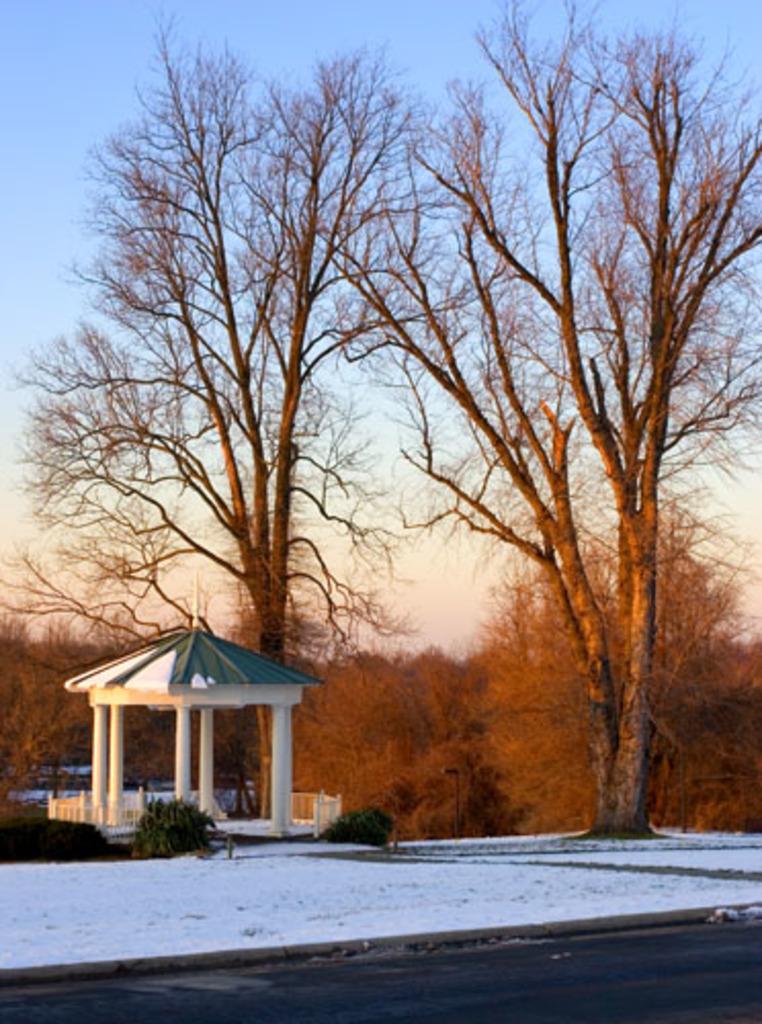In one or two sentences, can you explain what this image depicts? This picture shows trees and plants on the ground and we see snow and a blue cloudy sky. 